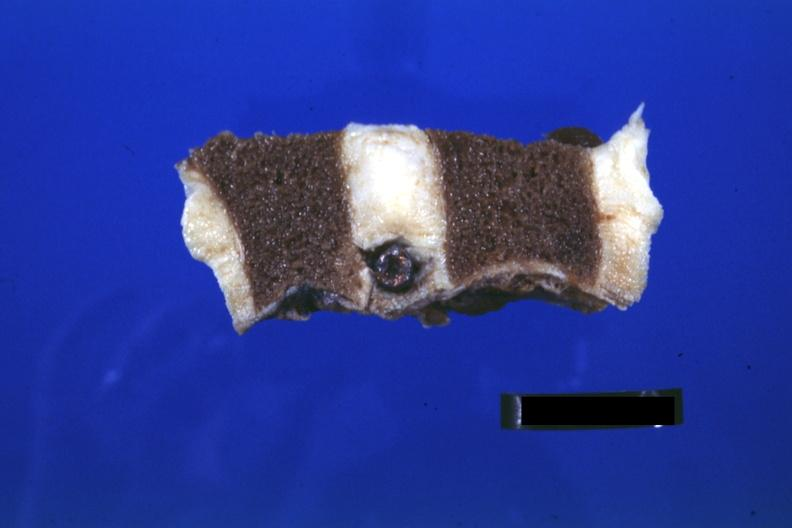what is present?
Answer the question using a single word or phrase. Joints 